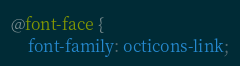Convert code to text. <code><loc_0><loc_0><loc_500><loc_500><_CSS_>@font-face {
    font-family: octicons-link;</code> 